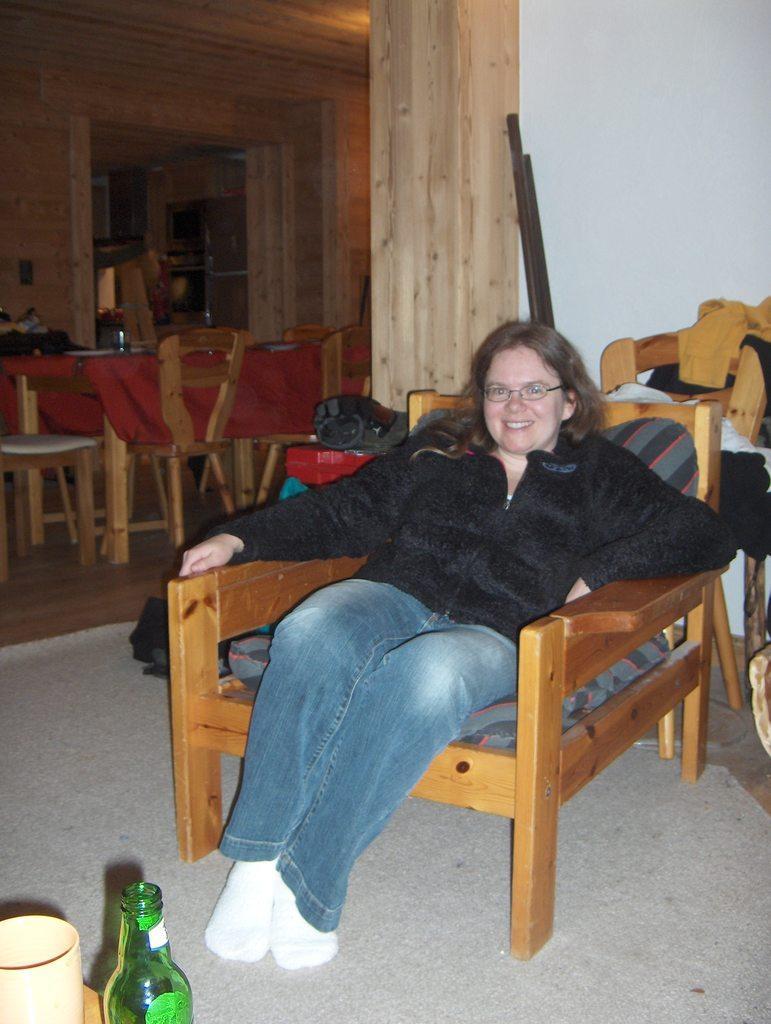Describe this image in one or two sentences. a person is sitting on a chair, wearing a black shirt and jeans. in the front there is a green glass bottle and a glass. behind her there is a white wall. at the right there is a table on which there is a red cloth and chairs around it. 